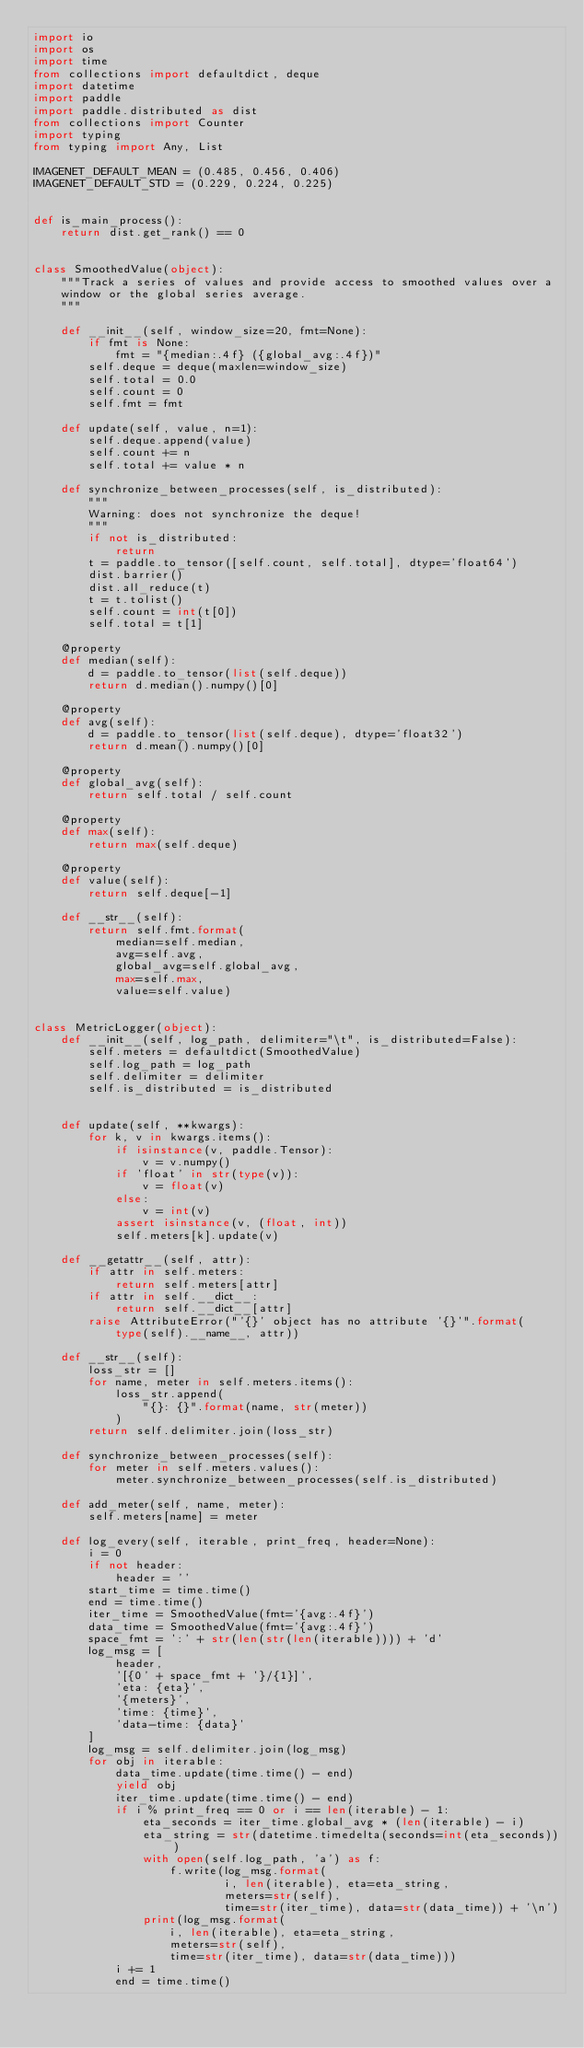<code> <loc_0><loc_0><loc_500><loc_500><_Python_>import io
import os
import time
from collections import defaultdict, deque
import datetime
import paddle
import paddle.distributed as dist
from collections import Counter
import typing
from typing import Any, List

IMAGENET_DEFAULT_MEAN = (0.485, 0.456, 0.406)
IMAGENET_DEFAULT_STD = (0.229, 0.224, 0.225)


def is_main_process():
    return dist.get_rank() == 0


class SmoothedValue(object):
    """Track a series of values and provide access to smoothed values over a
    window or the global series average.
    """

    def __init__(self, window_size=20, fmt=None):
        if fmt is None:
            fmt = "{median:.4f} ({global_avg:.4f})"
        self.deque = deque(maxlen=window_size)
        self.total = 0.0
        self.count = 0
        self.fmt = fmt

    def update(self, value, n=1):
        self.deque.append(value)
        self.count += n
        self.total += value * n

    def synchronize_between_processes(self, is_distributed):
        """
        Warning: does not synchronize the deque!
        """
        if not is_distributed:
            return
        t = paddle.to_tensor([self.count, self.total], dtype='float64')
        dist.barrier()
        dist.all_reduce(t)
        t = t.tolist()
        self.count = int(t[0])
        self.total = t[1]

    @property
    def median(self):
        d = paddle.to_tensor(list(self.deque))
        return d.median().numpy()[0]

    @property
    def avg(self):
        d = paddle.to_tensor(list(self.deque), dtype='float32')
        return d.mean().numpy()[0]

    @property
    def global_avg(self):
        return self.total / self.count

    @property
    def max(self):
        return max(self.deque)

    @property
    def value(self):
        return self.deque[-1]

    def __str__(self):
        return self.fmt.format(
            median=self.median,
            avg=self.avg,
            global_avg=self.global_avg,
            max=self.max,
            value=self.value)


class MetricLogger(object):
    def __init__(self, log_path, delimiter="\t", is_distributed=False):
        self.meters = defaultdict(SmoothedValue)
        self.log_path = log_path
        self.delimiter = delimiter
        self.is_distributed = is_distributed


    def update(self, **kwargs):
        for k, v in kwargs.items():
            if isinstance(v, paddle.Tensor):
                v = v.numpy()
            if 'float' in str(type(v)):
                v = float(v)
            else:
                v = int(v)
            assert isinstance(v, (float, int))
            self.meters[k].update(v)

    def __getattr__(self, attr):
        if attr in self.meters:
            return self.meters[attr]
        if attr in self.__dict__:
            return self.__dict__[attr]
        raise AttributeError("'{}' object has no attribute '{}'".format(
            type(self).__name__, attr))

    def __str__(self):
        loss_str = []
        for name, meter in self.meters.items():
            loss_str.append(
                "{}: {}".format(name, str(meter))
            )
        return self.delimiter.join(loss_str)

    def synchronize_between_processes(self):
        for meter in self.meters.values():
            meter.synchronize_between_processes(self.is_distributed)

    def add_meter(self, name, meter):
        self.meters[name] = meter

    def log_every(self, iterable, print_freq, header=None):
        i = 0
        if not header:
            header = ''
        start_time = time.time()
        end = time.time()
        iter_time = SmoothedValue(fmt='{avg:.4f}')
        data_time = SmoothedValue(fmt='{avg:.4f}')
        space_fmt = ':' + str(len(str(len(iterable)))) + 'd'
        log_msg = [
            header,
            '[{0' + space_fmt + '}/{1}]',
            'eta: {eta}',
            '{meters}',
            'time: {time}',
            'data-time: {data}'
        ]
        log_msg = self.delimiter.join(log_msg)
        for obj in iterable:
            data_time.update(time.time() - end)
            yield obj
            iter_time.update(time.time() - end)
            if i % print_freq == 0 or i == len(iterable) - 1:
                eta_seconds = iter_time.global_avg * (len(iterable) - i)
                eta_string = str(datetime.timedelta(seconds=int(eta_seconds)))
                with open(self.log_path, 'a') as f:
                    f.write(log_msg.format(
                            i, len(iterable), eta=eta_string,
                            meters=str(self),
                            time=str(iter_time), data=str(data_time)) + '\n')
                print(log_msg.format(
                    i, len(iterable), eta=eta_string,
                    meters=str(self),
                    time=str(iter_time), data=str(data_time)))
            i += 1
            end = time.time()</code> 